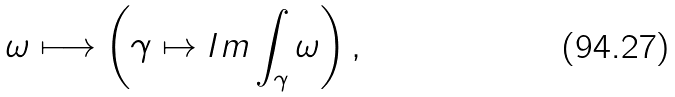Convert formula to latex. <formula><loc_0><loc_0><loc_500><loc_500>\omega \longmapsto \left ( \gamma \mapsto I m \int _ { \gamma } \omega \right ) ,</formula> 